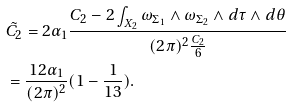<formula> <loc_0><loc_0><loc_500><loc_500>& \tilde { C _ { 2 } } = 2 \alpha _ { 1 } \frac { C _ { 2 } - 2 \int _ { X _ { 2 } } \omega _ { \Sigma _ { 1 } } \wedge \omega _ { \Sigma _ { 2 } } \wedge d \tau \wedge d \theta } { ( 2 \pi ) ^ { 2 } \frac { C _ { 2 } } { 6 } } \\ & = \frac { 1 2 \alpha _ { 1 } } { ( 2 \pi ) ^ { 2 } } ( 1 - \frac { 1 } { 1 3 } ) .</formula> 